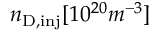Convert formula to latex. <formula><loc_0><loc_0><loc_500><loc_500>n _ { D , i n j } [ 1 0 ^ { 2 0 } m ^ { - 3 } ]</formula> 